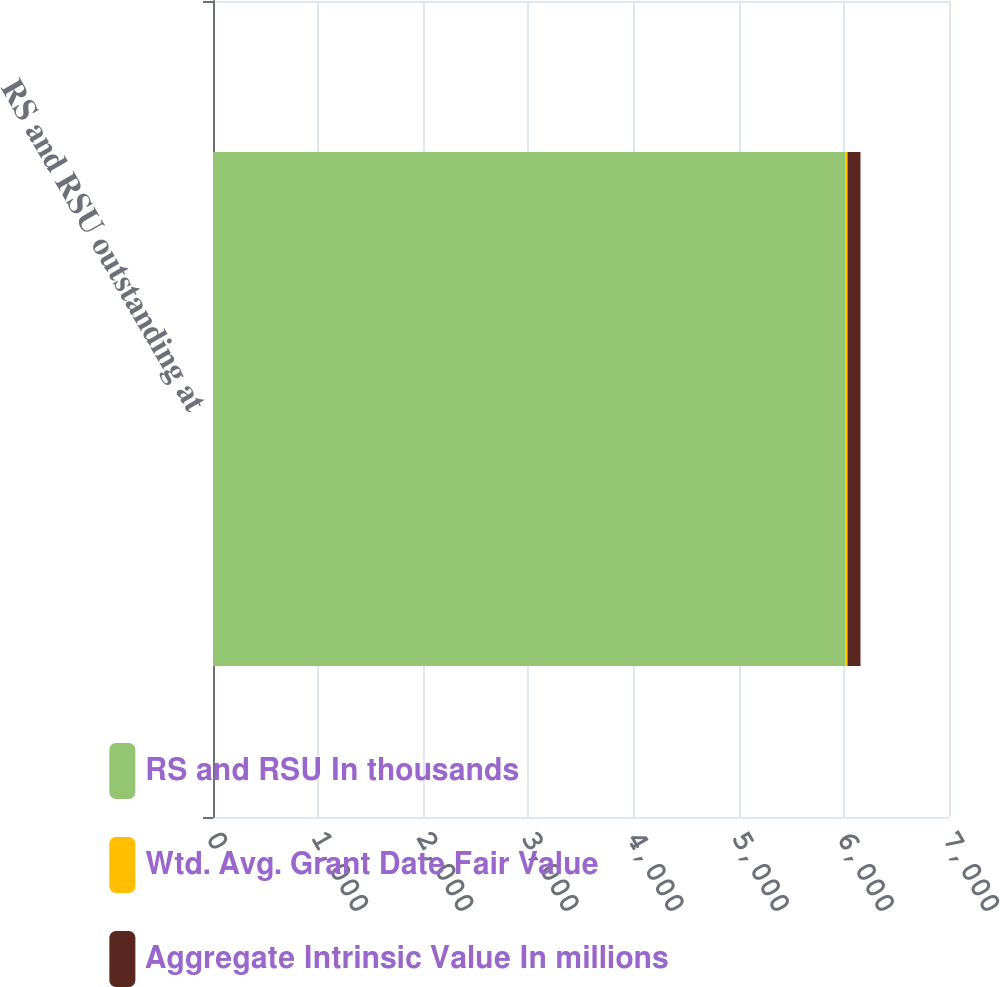<chart> <loc_0><loc_0><loc_500><loc_500><stacked_bar_chart><ecel><fcel>RS and RSU outstanding at<nl><fcel>RS and RSU In thousands<fcel>6016<nl><fcel>Wtd. Avg. Grant Date Fair Value<fcel>19<nl><fcel>Aggregate Intrinsic Value In millions<fcel>123<nl></chart> 